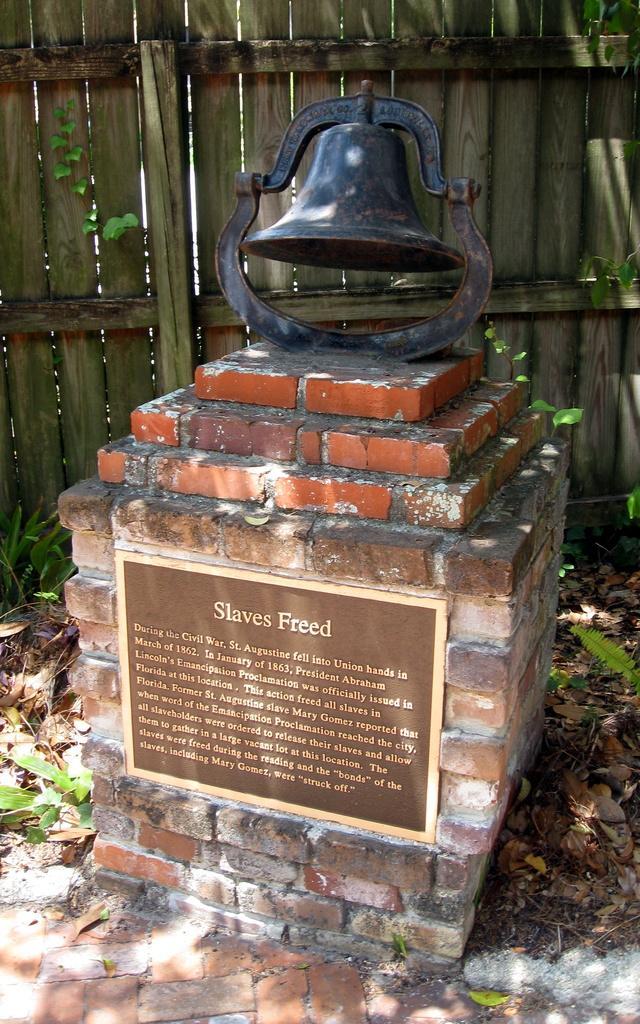Describe this image in one or two sentences. In the image we can see a memorial, this is a board, bell, wooden fence, dry leaves and a grass. 